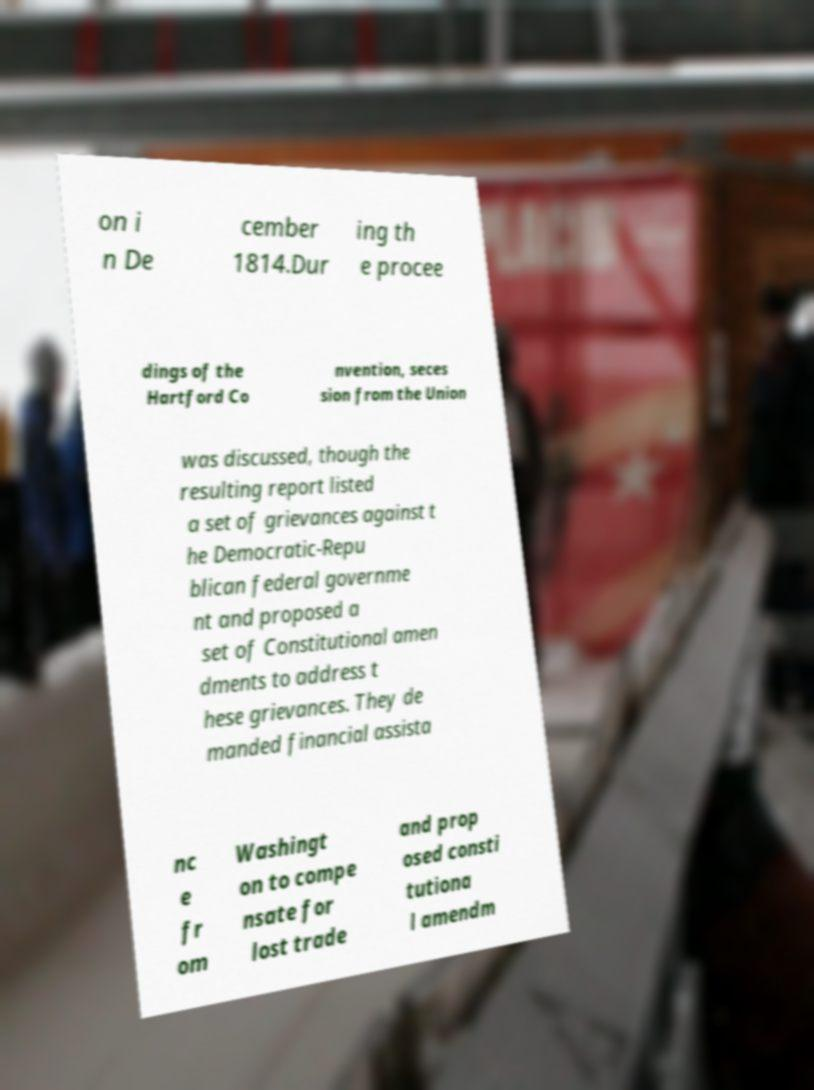Please identify and transcribe the text found in this image. on i n De cember 1814.Dur ing th e procee dings of the Hartford Co nvention, seces sion from the Union was discussed, though the resulting report listed a set of grievances against t he Democratic-Repu blican federal governme nt and proposed a set of Constitutional amen dments to address t hese grievances. They de manded financial assista nc e fr om Washingt on to compe nsate for lost trade and prop osed consti tutiona l amendm 